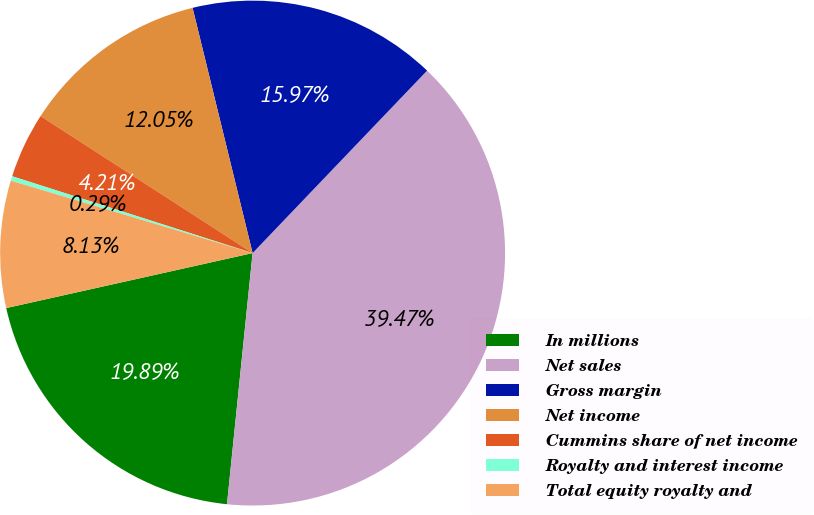Convert chart to OTSL. <chart><loc_0><loc_0><loc_500><loc_500><pie_chart><fcel>In millions<fcel>Net sales<fcel>Gross margin<fcel>Net income<fcel>Cummins share of net income<fcel>Royalty and interest income<fcel>Total equity royalty and<nl><fcel>19.89%<fcel>39.48%<fcel>15.97%<fcel>12.05%<fcel>4.21%<fcel>0.29%<fcel>8.13%<nl></chart> 